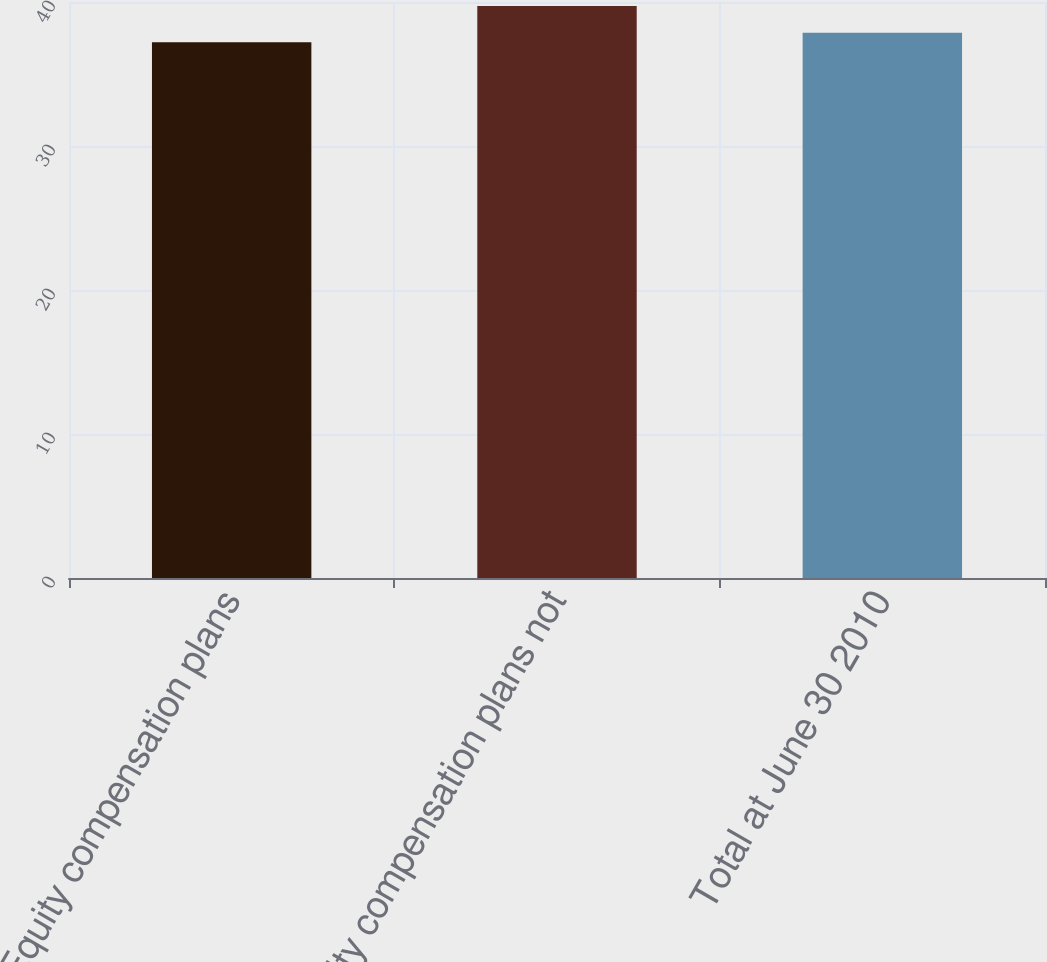Convert chart to OTSL. <chart><loc_0><loc_0><loc_500><loc_500><bar_chart><fcel>Equity compensation plans<fcel>Equity compensation plans not<fcel>Total at June 30 2010<nl><fcel>37.2<fcel>39.73<fcel>37.87<nl></chart> 